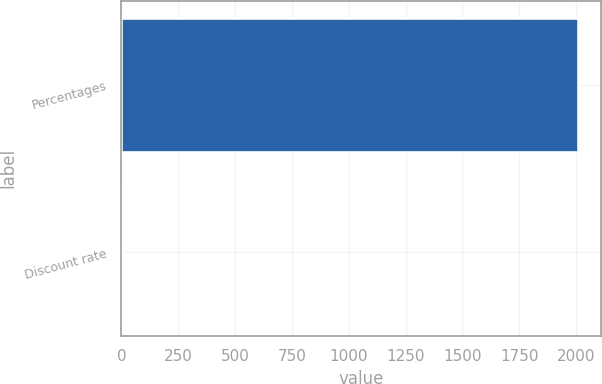Convert chart to OTSL. <chart><loc_0><loc_0><loc_500><loc_500><bar_chart><fcel>Percentages<fcel>Discount rate<nl><fcel>2008<fcel>6.25<nl></chart> 